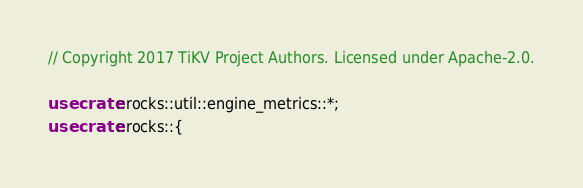<code> <loc_0><loc_0><loc_500><loc_500><_Rust_>// Copyright 2017 TiKV Project Authors. Licensed under Apache-2.0.

use crate::rocks::util::engine_metrics::*;
use crate::rocks::{</code> 